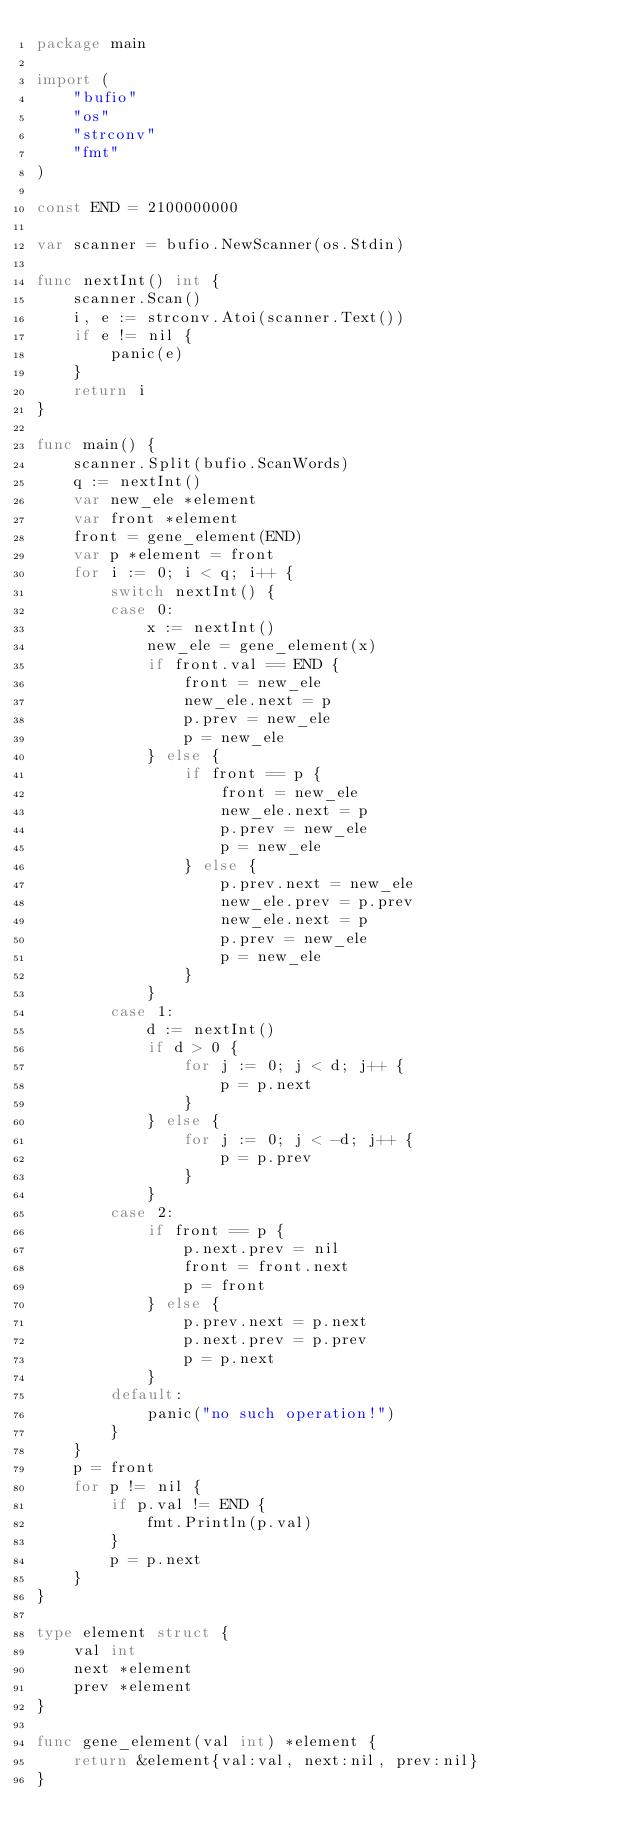<code> <loc_0><loc_0><loc_500><loc_500><_Go_>package main

import (
	"bufio"
	"os"
	"strconv"
	"fmt"
)

const END = 2100000000

var scanner = bufio.NewScanner(os.Stdin)

func nextInt() int {
	scanner.Scan()
	i, e := strconv.Atoi(scanner.Text())
	if e != nil {
		panic(e)
	}
	return i
}

func main() {
	scanner.Split(bufio.ScanWords)
	q := nextInt()
	var new_ele *element
	var front *element
	front = gene_element(END)
	var p *element = front
	for i := 0; i < q; i++ {
		switch nextInt() {
		case 0:
			x := nextInt()
			new_ele = gene_element(x)
			if front.val == END {
				front = new_ele
				new_ele.next = p
				p.prev = new_ele
				p = new_ele
			} else {
				if front == p {
					front = new_ele
					new_ele.next = p
					p.prev = new_ele
					p = new_ele
				} else {
					p.prev.next = new_ele
					new_ele.prev = p.prev
					new_ele.next = p
					p.prev = new_ele
					p = new_ele
				}
			}
		case 1:
			d := nextInt()
			if d > 0 {
				for j := 0; j < d; j++ {
					p = p.next
				}
			} else {
				for j := 0; j < -d; j++ {
					p = p.prev
				}
			}
		case 2:
			if front == p {
				p.next.prev = nil
				front = front.next
				p = front
			} else {
				p.prev.next = p.next
				p.next.prev = p.prev
				p = p.next
			}
		default:
			panic("no such operation!")
		}
	}
	p = front
	for p != nil {
		if p.val != END {
			fmt.Println(p.val)
		}
		p = p.next
	}
}

type element struct {
	val int
	next *element
	prev *element
}

func gene_element(val int) *element {
	return &element{val:val, next:nil, prev:nil}
}
</code> 